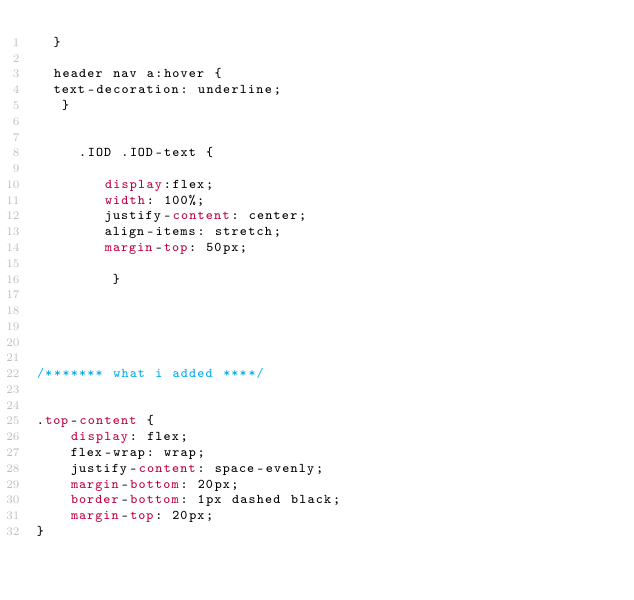<code> <loc_0><loc_0><loc_500><loc_500><_CSS_>  }
  
  header nav a:hover {
	text-decoration: underline;
	 }


     .IOD .IOD-text {
	
        display:flex;
        width: 100%;
        justify-content: center;
        align-items: stretch;
        margin-top: 50px;
        
         }

 



/******* what i added ****/


.top-content {
    display: flex;
    flex-wrap: wrap;
    justify-content: space-evenly;
    margin-bottom: 20px;
    border-bottom: 1px dashed black;
    margin-top: 20px;
}
</code> 